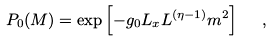Convert formula to latex. <formula><loc_0><loc_0><loc_500><loc_500>P _ { 0 } ( M ) = \exp \left [ - g _ { 0 } L _ { x } L ^ { ( \eta - 1 ) } m ^ { 2 } \right ] \ \ ,</formula> 